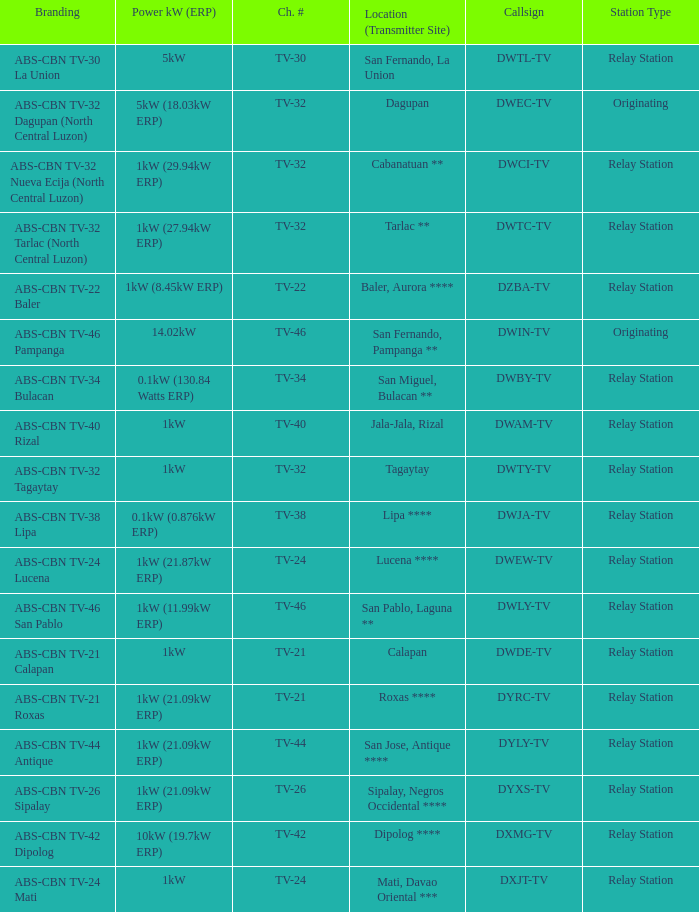What is the branding of the callsign DWCI-TV? ABS-CBN TV-32 Nueva Ecija (North Central Luzon). 